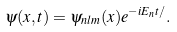Convert formula to latex. <formula><loc_0><loc_0><loc_500><loc_500>\psi ( { x } , t ) = \psi _ { n l m } ( { x } ) e ^ { - i E _ { n } t / } .</formula> 